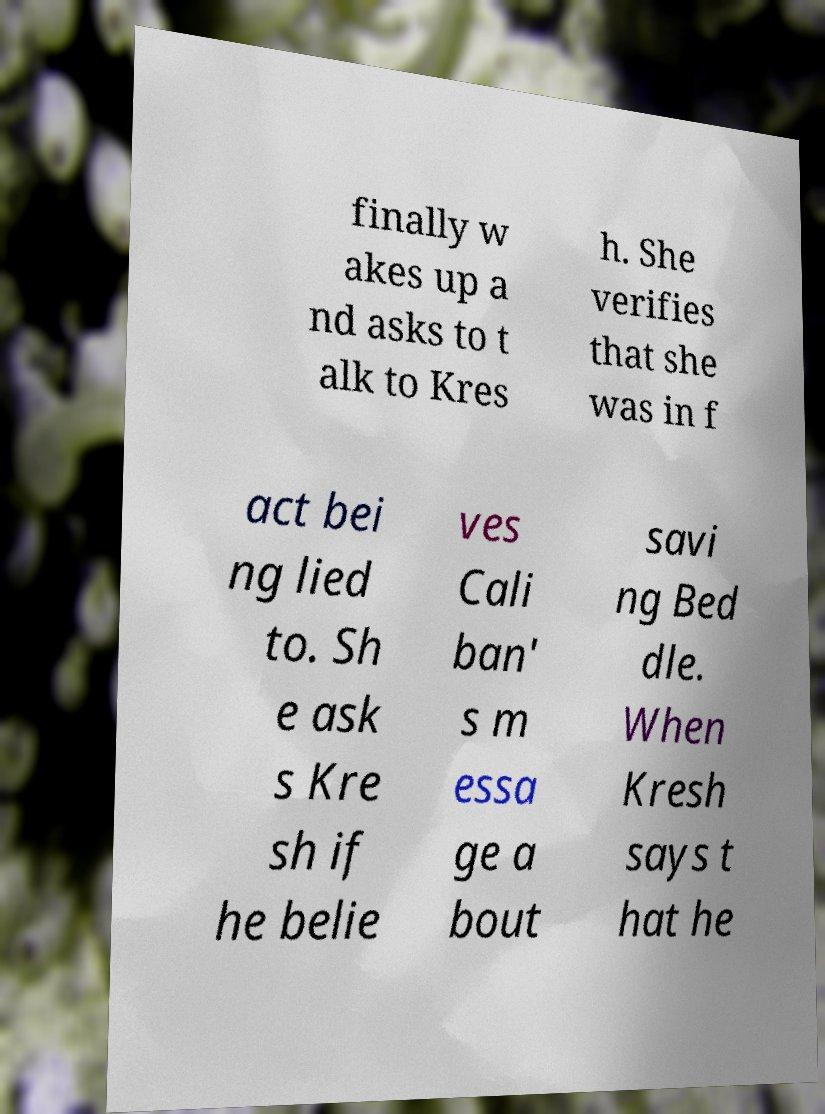Could you assist in decoding the text presented in this image and type it out clearly? finally w akes up a nd asks to t alk to Kres h. She verifies that she was in f act bei ng lied to. Sh e ask s Kre sh if he belie ves Cali ban' s m essa ge a bout savi ng Bed dle. When Kresh says t hat he 